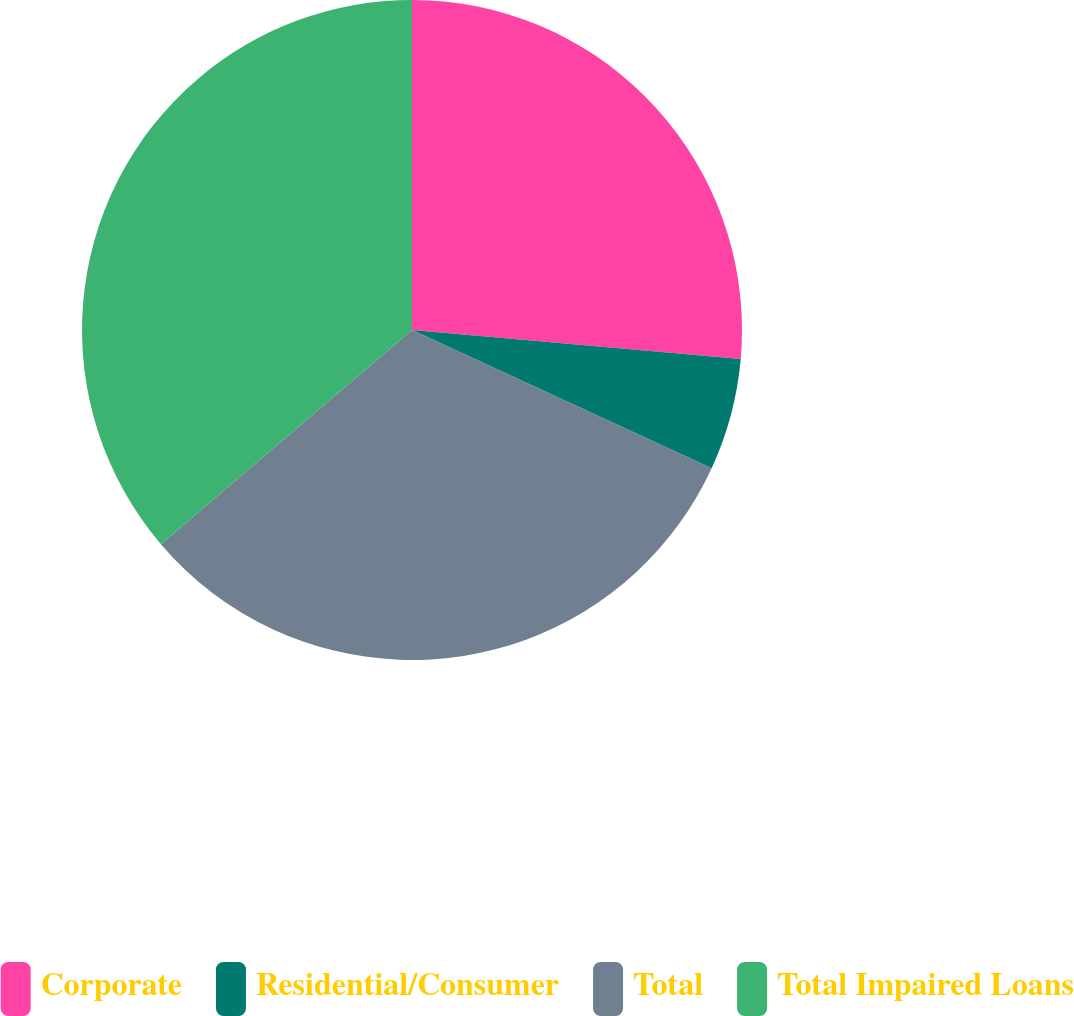Convert chart. <chart><loc_0><loc_0><loc_500><loc_500><pie_chart><fcel>Corporate<fcel>Residential/Consumer<fcel>Total<fcel>Total Impaired Loans<nl><fcel>26.4%<fcel>5.48%<fcel>31.88%<fcel>36.24%<nl></chart> 